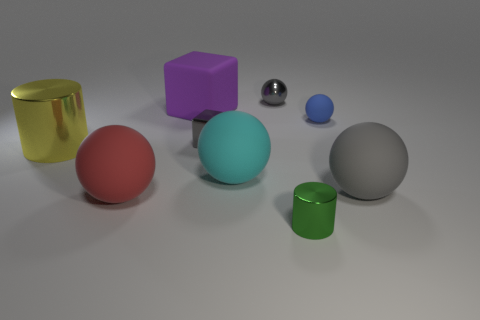What number of metallic things are the same color as the tiny metallic block? 1 